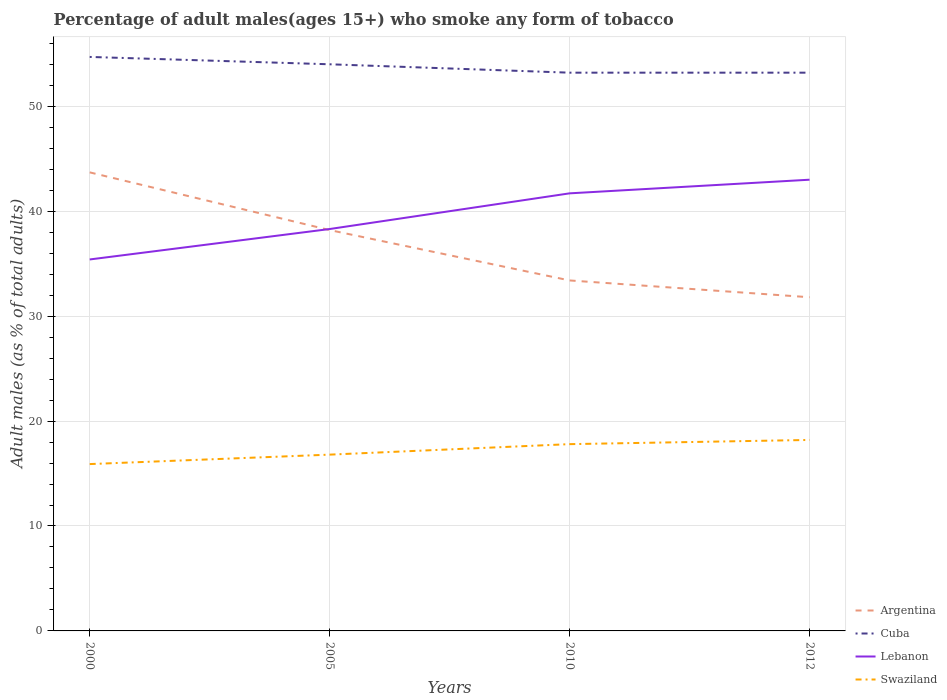How many different coloured lines are there?
Provide a succinct answer. 4. Across all years, what is the maximum percentage of adult males who smoke in Swaziland?
Your answer should be compact. 15.9. In which year was the percentage of adult males who smoke in Argentina maximum?
Your response must be concise. 2012. What is the total percentage of adult males who smoke in Swaziland in the graph?
Provide a succinct answer. -0.9. What is the difference between the highest and the lowest percentage of adult males who smoke in Argentina?
Your answer should be very brief. 2. How many lines are there?
Ensure brevity in your answer.  4. How many years are there in the graph?
Keep it short and to the point. 4. What is the difference between two consecutive major ticks on the Y-axis?
Give a very brief answer. 10. Are the values on the major ticks of Y-axis written in scientific E-notation?
Give a very brief answer. No. Does the graph contain any zero values?
Your answer should be very brief. No. Does the graph contain grids?
Your response must be concise. Yes. Where does the legend appear in the graph?
Your answer should be very brief. Bottom right. How many legend labels are there?
Your answer should be very brief. 4. What is the title of the graph?
Offer a terse response. Percentage of adult males(ages 15+) who smoke any form of tobacco. What is the label or title of the Y-axis?
Your response must be concise. Adult males (as % of total adults). What is the Adult males (as % of total adults) of Argentina in 2000?
Offer a very short reply. 43.7. What is the Adult males (as % of total adults) of Cuba in 2000?
Keep it short and to the point. 54.7. What is the Adult males (as % of total adults) of Lebanon in 2000?
Offer a very short reply. 35.4. What is the Adult males (as % of total adults) in Swaziland in 2000?
Provide a short and direct response. 15.9. What is the Adult males (as % of total adults) of Argentina in 2005?
Ensure brevity in your answer.  38.2. What is the Adult males (as % of total adults) of Lebanon in 2005?
Your response must be concise. 38.3. What is the Adult males (as % of total adults) of Argentina in 2010?
Your answer should be compact. 33.4. What is the Adult males (as % of total adults) in Cuba in 2010?
Provide a short and direct response. 53.2. What is the Adult males (as % of total adults) of Lebanon in 2010?
Your response must be concise. 41.7. What is the Adult males (as % of total adults) of Argentina in 2012?
Provide a succinct answer. 31.8. What is the Adult males (as % of total adults) of Cuba in 2012?
Ensure brevity in your answer.  53.2. What is the Adult males (as % of total adults) of Lebanon in 2012?
Keep it short and to the point. 43. What is the Adult males (as % of total adults) in Swaziland in 2012?
Make the answer very short. 18.2. Across all years, what is the maximum Adult males (as % of total adults) of Argentina?
Offer a very short reply. 43.7. Across all years, what is the maximum Adult males (as % of total adults) of Cuba?
Offer a very short reply. 54.7. Across all years, what is the maximum Adult males (as % of total adults) in Lebanon?
Your answer should be compact. 43. Across all years, what is the minimum Adult males (as % of total adults) of Argentina?
Give a very brief answer. 31.8. Across all years, what is the minimum Adult males (as % of total adults) of Cuba?
Offer a very short reply. 53.2. Across all years, what is the minimum Adult males (as % of total adults) of Lebanon?
Your answer should be compact. 35.4. Across all years, what is the minimum Adult males (as % of total adults) in Swaziland?
Your response must be concise. 15.9. What is the total Adult males (as % of total adults) in Argentina in the graph?
Your answer should be compact. 147.1. What is the total Adult males (as % of total adults) in Cuba in the graph?
Keep it short and to the point. 215.1. What is the total Adult males (as % of total adults) of Lebanon in the graph?
Your response must be concise. 158.4. What is the total Adult males (as % of total adults) in Swaziland in the graph?
Your answer should be very brief. 68.7. What is the difference between the Adult males (as % of total adults) of Argentina in 2000 and that in 2005?
Offer a very short reply. 5.5. What is the difference between the Adult males (as % of total adults) of Cuba in 2000 and that in 2010?
Ensure brevity in your answer.  1.5. What is the difference between the Adult males (as % of total adults) of Swaziland in 2000 and that in 2010?
Offer a terse response. -1.9. What is the difference between the Adult males (as % of total adults) in Argentina in 2000 and that in 2012?
Your response must be concise. 11.9. What is the difference between the Adult males (as % of total adults) in Cuba in 2000 and that in 2012?
Your response must be concise. 1.5. What is the difference between the Adult males (as % of total adults) of Lebanon in 2000 and that in 2012?
Your response must be concise. -7.6. What is the difference between the Adult males (as % of total adults) in Swaziland in 2000 and that in 2012?
Your response must be concise. -2.3. What is the difference between the Adult males (as % of total adults) in Argentina in 2005 and that in 2010?
Offer a terse response. 4.8. What is the difference between the Adult males (as % of total adults) in Cuba in 2005 and that in 2010?
Your answer should be compact. 0.8. What is the difference between the Adult males (as % of total adults) in Lebanon in 2005 and that in 2010?
Provide a succinct answer. -3.4. What is the difference between the Adult males (as % of total adults) of Argentina in 2005 and that in 2012?
Offer a terse response. 6.4. What is the difference between the Adult males (as % of total adults) of Lebanon in 2005 and that in 2012?
Offer a very short reply. -4.7. What is the difference between the Adult males (as % of total adults) in Swaziland in 2005 and that in 2012?
Your answer should be very brief. -1.4. What is the difference between the Adult males (as % of total adults) of Argentina in 2010 and that in 2012?
Offer a very short reply. 1.6. What is the difference between the Adult males (as % of total adults) of Swaziland in 2010 and that in 2012?
Your answer should be compact. -0.4. What is the difference between the Adult males (as % of total adults) in Argentina in 2000 and the Adult males (as % of total adults) in Lebanon in 2005?
Give a very brief answer. 5.4. What is the difference between the Adult males (as % of total adults) of Argentina in 2000 and the Adult males (as % of total adults) of Swaziland in 2005?
Your response must be concise. 26.9. What is the difference between the Adult males (as % of total adults) of Cuba in 2000 and the Adult males (as % of total adults) of Lebanon in 2005?
Provide a succinct answer. 16.4. What is the difference between the Adult males (as % of total adults) of Cuba in 2000 and the Adult males (as % of total adults) of Swaziland in 2005?
Give a very brief answer. 37.9. What is the difference between the Adult males (as % of total adults) of Lebanon in 2000 and the Adult males (as % of total adults) of Swaziland in 2005?
Your answer should be very brief. 18.6. What is the difference between the Adult males (as % of total adults) in Argentina in 2000 and the Adult males (as % of total adults) in Lebanon in 2010?
Your answer should be compact. 2. What is the difference between the Adult males (as % of total adults) of Argentina in 2000 and the Adult males (as % of total adults) of Swaziland in 2010?
Your answer should be very brief. 25.9. What is the difference between the Adult males (as % of total adults) in Cuba in 2000 and the Adult males (as % of total adults) in Lebanon in 2010?
Offer a terse response. 13. What is the difference between the Adult males (as % of total adults) in Cuba in 2000 and the Adult males (as % of total adults) in Swaziland in 2010?
Your answer should be compact. 36.9. What is the difference between the Adult males (as % of total adults) in Lebanon in 2000 and the Adult males (as % of total adults) in Swaziland in 2010?
Keep it short and to the point. 17.6. What is the difference between the Adult males (as % of total adults) in Cuba in 2000 and the Adult males (as % of total adults) in Swaziland in 2012?
Offer a terse response. 36.5. What is the difference between the Adult males (as % of total adults) in Argentina in 2005 and the Adult males (as % of total adults) in Swaziland in 2010?
Provide a short and direct response. 20.4. What is the difference between the Adult males (as % of total adults) in Cuba in 2005 and the Adult males (as % of total adults) in Lebanon in 2010?
Your answer should be very brief. 12.3. What is the difference between the Adult males (as % of total adults) in Cuba in 2005 and the Adult males (as % of total adults) in Swaziland in 2010?
Offer a very short reply. 36.2. What is the difference between the Adult males (as % of total adults) of Cuba in 2005 and the Adult males (as % of total adults) of Swaziland in 2012?
Ensure brevity in your answer.  35.8. What is the difference between the Adult males (as % of total adults) in Lebanon in 2005 and the Adult males (as % of total adults) in Swaziland in 2012?
Your answer should be compact. 20.1. What is the difference between the Adult males (as % of total adults) in Argentina in 2010 and the Adult males (as % of total adults) in Cuba in 2012?
Give a very brief answer. -19.8. What is the difference between the Adult males (as % of total adults) in Cuba in 2010 and the Adult males (as % of total adults) in Swaziland in 2012?
Offer a terse response. 35. What is the average Adult males (as % of total adults) in Argentina per year?
Make the answer very short. 36.77. What is the average Adult males (as % of total adults) of Cuba per year?
Your answer should be compact. 53.77. What is the average Adult males (as % of total adults) of Lebanon per year?
Make the answer very short. 39.6. What is the average Adult males (as % of total adults) of Swaziland per year?
Ensure brevity in your answer.  17.18. In the year 2000, what is the difference between the Adult males (as % of total adults) of Argentina and Adult males (as % of total adults) of Cuba?
Your answer should be very brief. -11. In the year 2000, what is the difference between the Adult males (as % of total adults) in Argentina and Adult males (as % of total adults) in Swaziland?
Your response must be concise. 27.8. In the year 2000, what is the difference between the Adult males (as % of total adults) of Cuba and Adult males (as % of total adults) of Lebanon?
Your answer should be compact. 19.3. In the year 2000, what is the difference between the Adult males (as % of total adults) of Cuba and Adult males (as % of total adults) of Swaziland?
Offer a very short reply. 38.8. In the year 2005, what is the difference between the Adult males (as % of total adults) in Argentina and Adult males (as % of total adults) in Cuba?
Your answer should be compact. -15.8. In the year 2005, what is the difference between the Adult males (as % of total adults) in Argentina and Adult males (as % of total adults) in Swaziland?
Make the answer very short. 21.4. In the year 2005, what is the difference between the Adult males (as % of total adults) of Cuba and Adult males (as % of total adults) of Swaziland?
Make the answer very short. 37.2. In the year 2010, what is the difference between the Adult males (as % of total adults) in Argentina and Adult males (as % of total adults) in Cuba?
Provide a short and direct response. -19.8. In the year 2010, what is the difference between the Adult males (as % of total adults) of Cuba and Adult males (as % of total adults) of Lebanon?
Offer a very short reply. 11.5. In the year 2010, what is the difference between the Adult males (as % of total adults) in Cuba and Adult males (as % of total adults) in Swaziland?
Ensure brevity in your answer.  35.4. In the year 2010, what is the difference between the Adult males (as % of total adults) in Lebanon and Adult males (as % of total adults) in Swaziland?
Provide a short and direct response. 23.9. In the year 2012, what is the difference between the Adult males (as % of total adults) in Argentina and Adult males (as % of total adults) in Cuba?
Offer a very short reply. -21.4. In the year 2012, what is the difference between the Adult males (as % of total adults) of Cuba and Adult males (as % of total adults) of Swaziland?
Your answer should be compact. 35. In the year 2012, what is the difference between the Adult males (as % of total adults) of Lebanon and Adult males (as % of total adults) of Swaziland?
Make the answer very short. 24.8. What is the ratio of the Adult males (as % of total adults) of Argentina in 2000 to that in 2005?
Your answer should be compact. 1.14. What is the ratio of the Adult males (as % of total adults) in Cuba in 2000 to that in 2005?
Ensure brevity in your answer.  1.01. What is the ratio of the Adult males (as % of total adults) of Lebanon in 2000 to that in 2005?
Make the answer very short. 0.92. What is the ratio of the Adult males (as % of total adults) of Swaziland in 2000 to that in 2005?
Offer a terse response. 0.95. What is the ratio of the Adult males (as % of total adults) of Argentina in 2000 to that in 2010?
Offer a terse response. 1.31. What is the ratio of the Adult males (as % of total adults) of Cuba in 2000 to that in 2010?
Your answer should be compact. 1.03. What is the ratio of the Adult males (as % of total adults) in Lebanon in 2000 to that in 2010?
Provide a succinct answer. 0.85. What is the ratio of the Adult males (as % of total adults) of Swaziland in 2000 to that in 2010?
Give a very brief answer. 0.89. What is the ratio of the Adult males (as % of total adults) of Argentina in 2000 to that in 2012?
Offer a very short reply. 1.37. What is the ratio of the Adult males (as % of total adults) in Cuba in 2000 to that in 2012?
Provide a short and direct response. 1.03. What is the ratio of the Adult males (as % of total adults) in Lebanon in 2000 to that in 2012?
Make the answer very short. 0.82. What is the ratio of the Adult males (as % of total adults) of Swaziland in 2000 to that in 2012?
Your answer should be compact. 0.87. What is the ratio of the Adult males (as % of total adults) in Argentina in 2005 to that in 2010?
Offer a very short reply. 1.14. What is the ratio of the Adult males (as % of total adults) in Lebanon in 2005 to that in 2010?
Offer a very short reply. 0.92. What is the ratio of the Adult males (as % of total adults) of Swaziland in 2005 to that in 2010?
Your answer should be compact. 0.94. What is the ratio of the Adult males (as % of total adults) in Argentina in 2005 to that in 2012?
Offer a very short reply. 1.2. What is the ratio of the Adult males (as % of total adults) in Cuba in 2005 to that in 2012?
Your response must be concise. 1.01. What is the ratio of the Adult males (as % of total adults) of Lebanon in 2005 to that in 2012?
Keep it short and to the point. 0.89. What is the ratio of the Adult males (as % of total adults) in Swaziland in 2005 to that in 2012?
Provide a succinct answer. 0.92. What is the ratio of the Adult males (as % of total adults) in Argentina in 2010 to that in 2012?
Your answer should be very brief. 1.05. What is the ratio of the Adult males (as % of total adults) of Cuba in 2010 to that in 2012?
Provide a succinct answer. 1. What is the ratio of the Adult males (as % of total adults) in Lebanon in 2010 to that in 2012?
Provide a succinct answer. 0.97. What is the difference between the highest and the second highest Adult males (as % of total adults) of Argentina?
Offer a terse response. 5.5. What is the difference between the highest and the lowest Adult males (as % of total adults) in Argentina?
Your response must be concise. 11.9. 